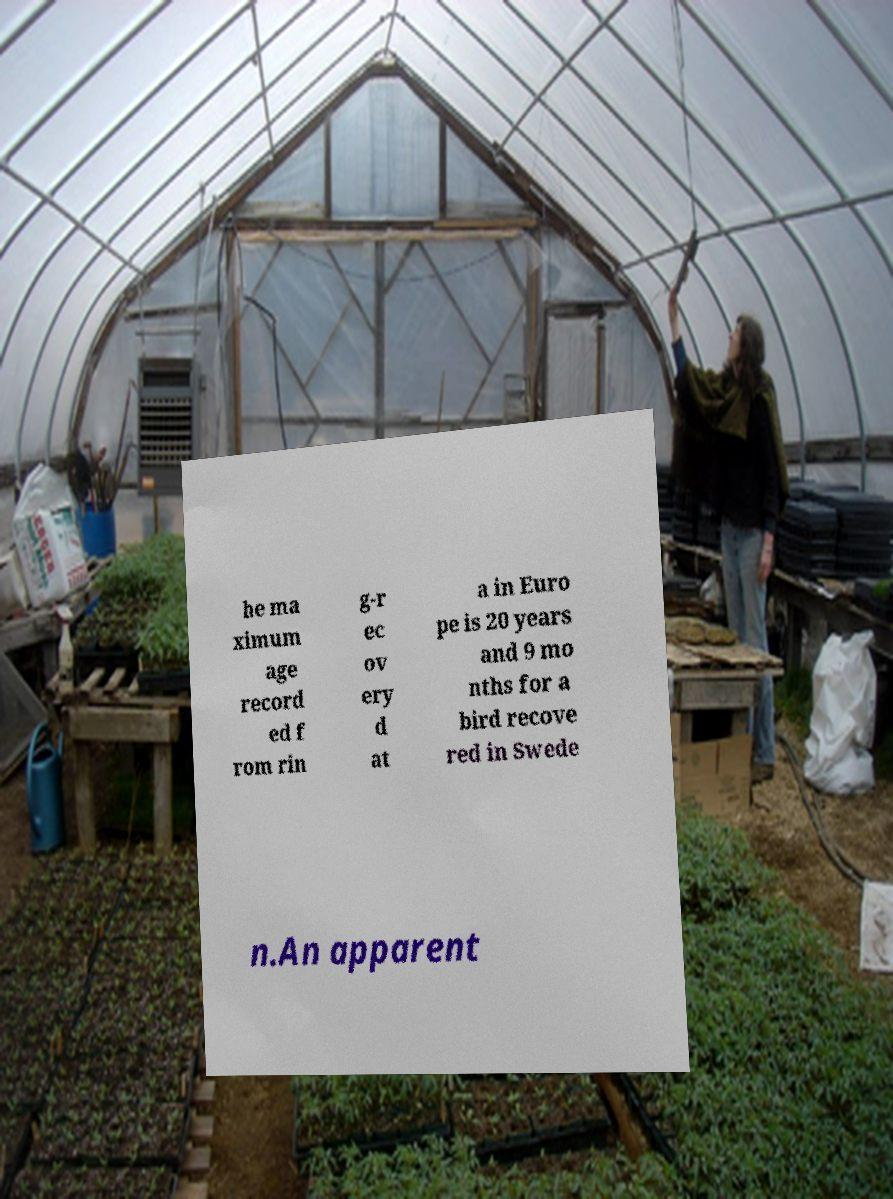Could you extract and type out the text from this image? he ma ximum age record ed f rom rin g-r ec ov ery d at a in Euro pe is 20 years and 9 mo nths for a bird recove red in Swede n.An apparent 